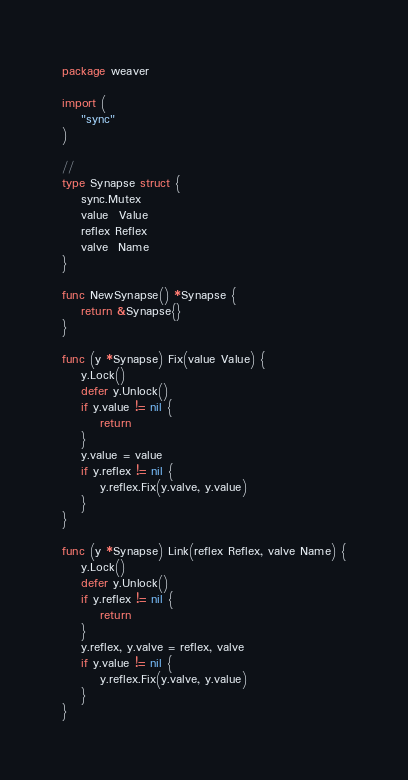Convert code to text. <code><loc_0><loc_0><loc_500><loc_500><_Go_>package weaver

import (
	"sync"
)

//
type Synapse struct {
	sync.Mutex
	value  Value
	reflex Reflex
	valve  Name
}

func NewSynapse() *Synapse {
	return &Synapse{}
}

func (y *Synapse) Fix(value Value) {
	y.Lock()
	defer y.Unlock()
	if y.value != nil {
		return
	}
	y.value = value
	if y.reflex != nil {
		y.reflex.Fix(y.valve, y.value)
	}
}

func (y *Synapse) Link(reflex Reflex, valve Name) {
	y.Lock()
	defer y.Unlock()
	if y.reflex != nil {
		return
	}
	y.reflex, y.valve = reflex, valve
	if y.value != nil {
		y.reflex.Fix(y.valve, y.value)
	}
}
</code> 